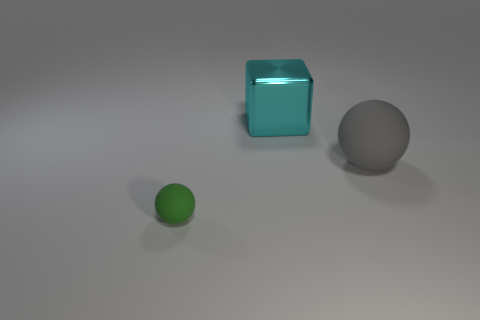Add 1 small purple cubes. How many objects exist? 4 Subtract all blocks. How many objects are left? 2 Add 2 metal objects. How many metal objects exist? 3 Subtract 0 green cylinders. How many objects are left? 3 Subtract all green things. Subtract all tiny green spheres. How many objects are left? 1 Add 3 balls. How many balls are left? 5 